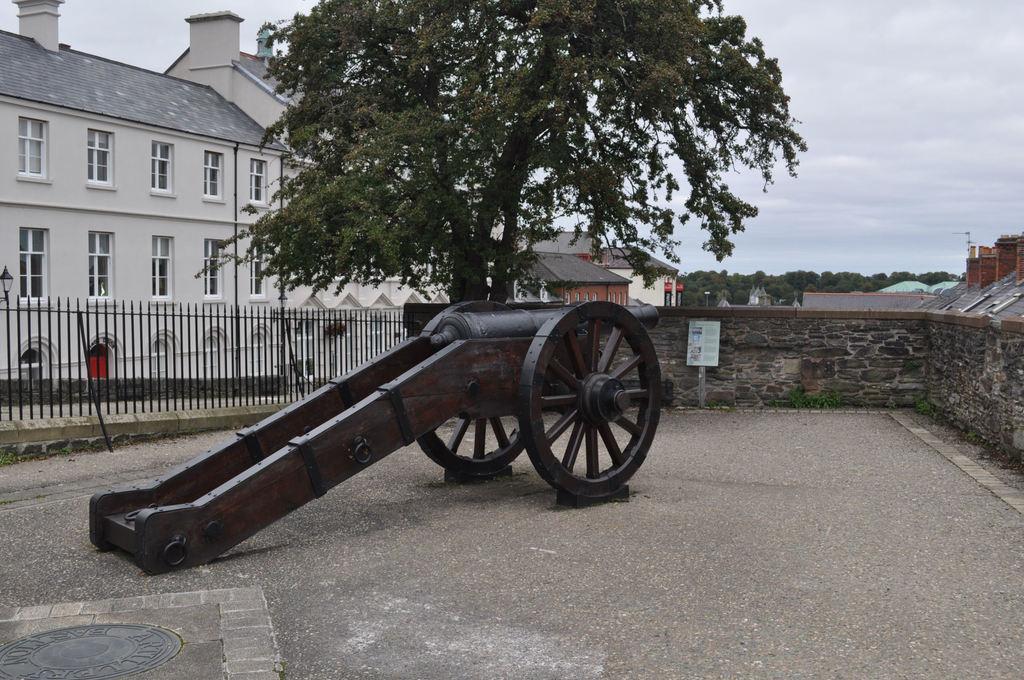Describe this image in one or two sentences. In this image there is a cannon on the ground. Behind it there is a railing to the wall. Behind the wall there is a tree. In the background there are buildings and trees. At the top there is the sky. 